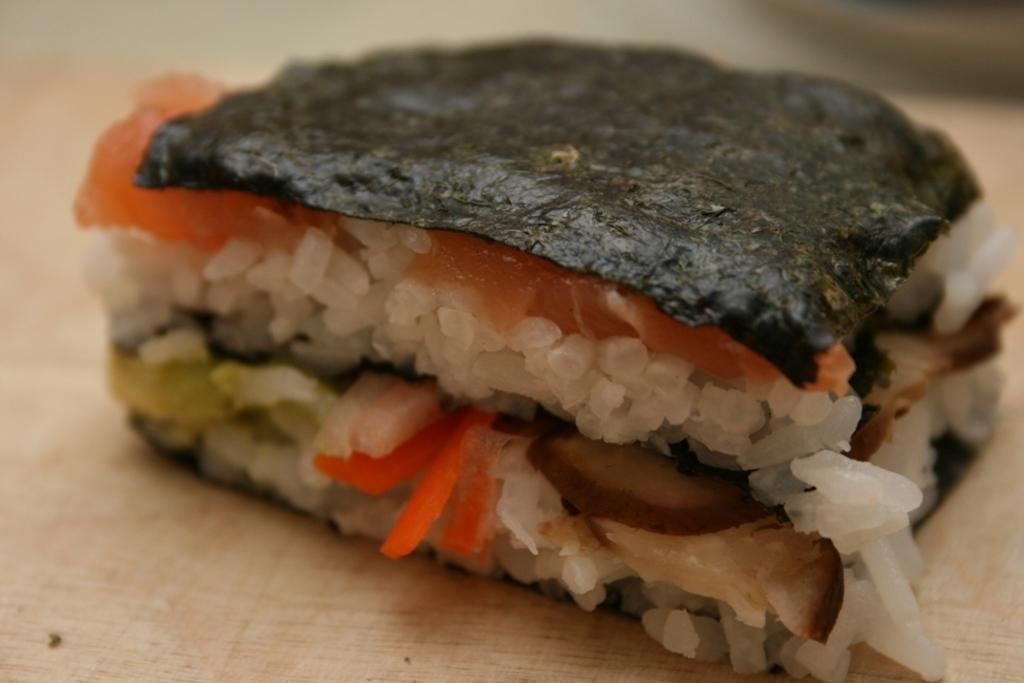Could you give a brief overview of what you see in this image? In this picture we can see food on a platform. 